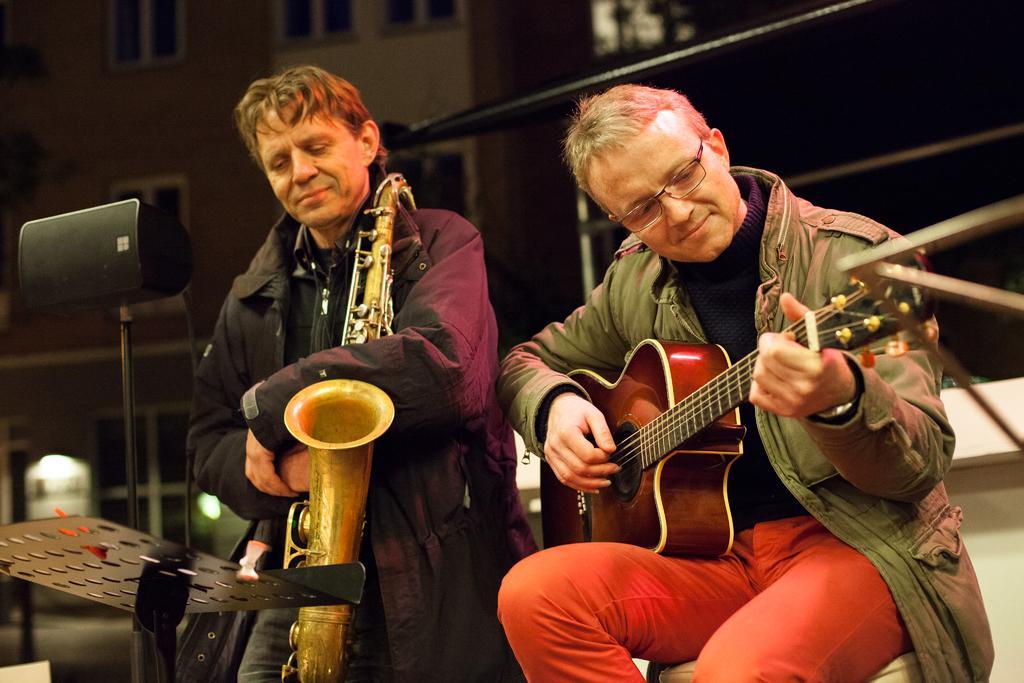In one or two sentences, can you explain what this image depicts? There are two persons in this image. The person at the right side is sitting and holding a guitar in his hand. The person in the center is holding a musical instrument in his hand. At the left side there is a black colour speaker. In the background there is a building. 